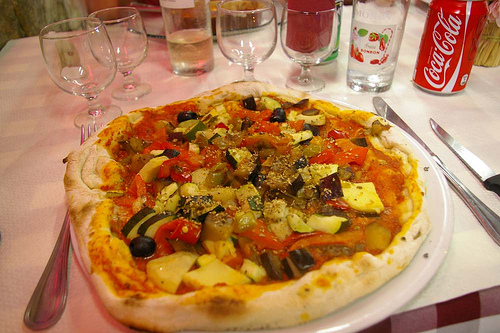Are there any knives near the plate? Yes, indeed there are knives placed within easy reach near the plate, perfect for slicing through the delightful meal. 